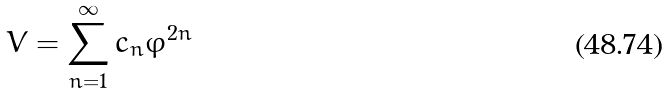Convert formula to latex. <formula><loc_0><loc_0><loc_500><loc_500>V = \sum _ { n = 1 } ^ { \infty } c _ { n } \varphi ^ { 2 n }</formula> 